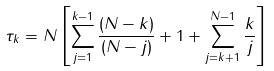Convert formula to latex. <formula><loc_0><loc_0><loc_500><loc_500>\tau _ { k } = N \left [ \sum ^ { k - 1 } _ { j = 1 } \frac { ( N - k ) } { ( N - j ) } + 1 + \sum ^ { N - 1 } _ { j = k + 1 } \frac { k } { j } \right ]</formula> 